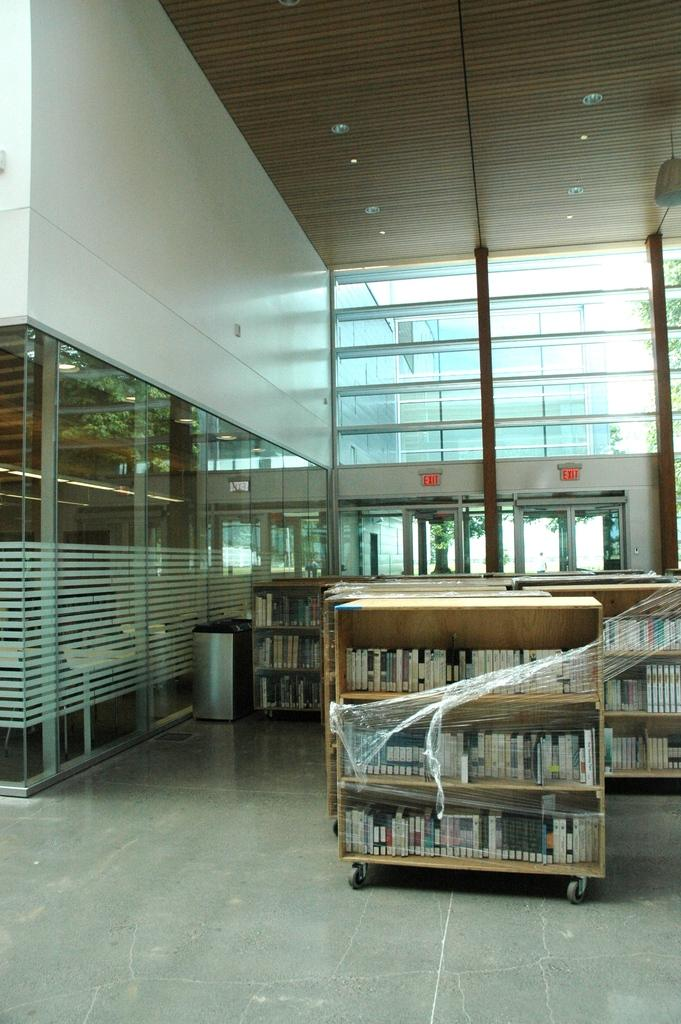What type of wall is visible in the image? There is a framed glass wall in the image. What can be seen on the shelves in the image? Objects are present on shelves in the image. What type of lighting is present in the image? There are lights on the ceiling in the image. What else is visible on the floor in the image? There are other objects on the floor in the image. Where is the image taken? The image is an inside view of a building. How many tails are visible on the objects on the floor in the image? There are no tails visible on the objects on the floor in the image. 